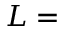Convert formula to latex. <formula><loc_0><loc_0><loc_500><loc_500>L =</formula> 